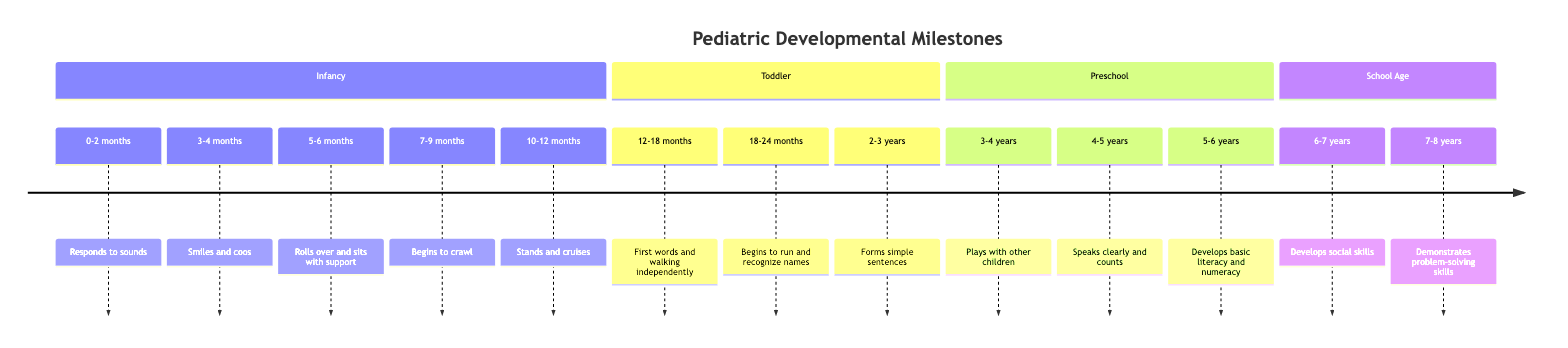what milestone is associated with the age range 0-2 months? The diagram shows that the milestone for the age range 0-2 months is "Responds to sounds." This information is directly derived from the timeline's first element under the section "Infancy."
Answer: Responds to sounds how many milestones are listed in the toddler section? The toddler section contains four milestones: "First words and walking independently," "Begins to run and recognize names," "Forms simple sentences," and "Develops basic literacy and numeracy." Counting these gives a total of four milestones.
Answer: 4 what is the primary motor milestone for children aged 10-12 months? According to the diagram, the primary motor milestone for children aged 10-12 months is "Stands and cruises." This is specifically mentioned in the timeline for that age range.
Answer: Stands and cruises which age range first mentions verbal communication? The first mention of verbal communication in the timeline occurs at the age range of 12-18 months, under the milestone "First words and walking independently." This indicates that this is the earliest age when verbal communication is noted.
Answer: 12-18 months what is the last milestone listed on the timeline? The last milestone on the timeline is "Demonstrates problem-solving skills," associated with the age range of 7-8 years. This is identified as the final entry in the "School Age" section of the timeline.
Answer: Demonstrates problem-solving skills what milestone occurs as children transition from toddler to preschool? The transition from toddler to preschool occurs with the milestone "Plays with other children," which is listed at the age range of 3-4 years. This marks the beginning of the preschool section, following the toddler milestones.
Answer: Plays with other children which age group first shows the ability to run? The ability to run is first noted in the age range of 18-24 months, where the milestone is "Begins to run and recognize names of familiar people." This indicates that running begins after the age of 18 months.
Answer: 18-24 months how is social skill development characterized at age 6-7 years? At the age of 6-7 years, social skill development is characterized by "Develops social skills and enjoys group activities." This milestone indicates that children at this age start forming peer relationships and engaging in group settings.
Answer: Develops social skills and enjoys group activities 